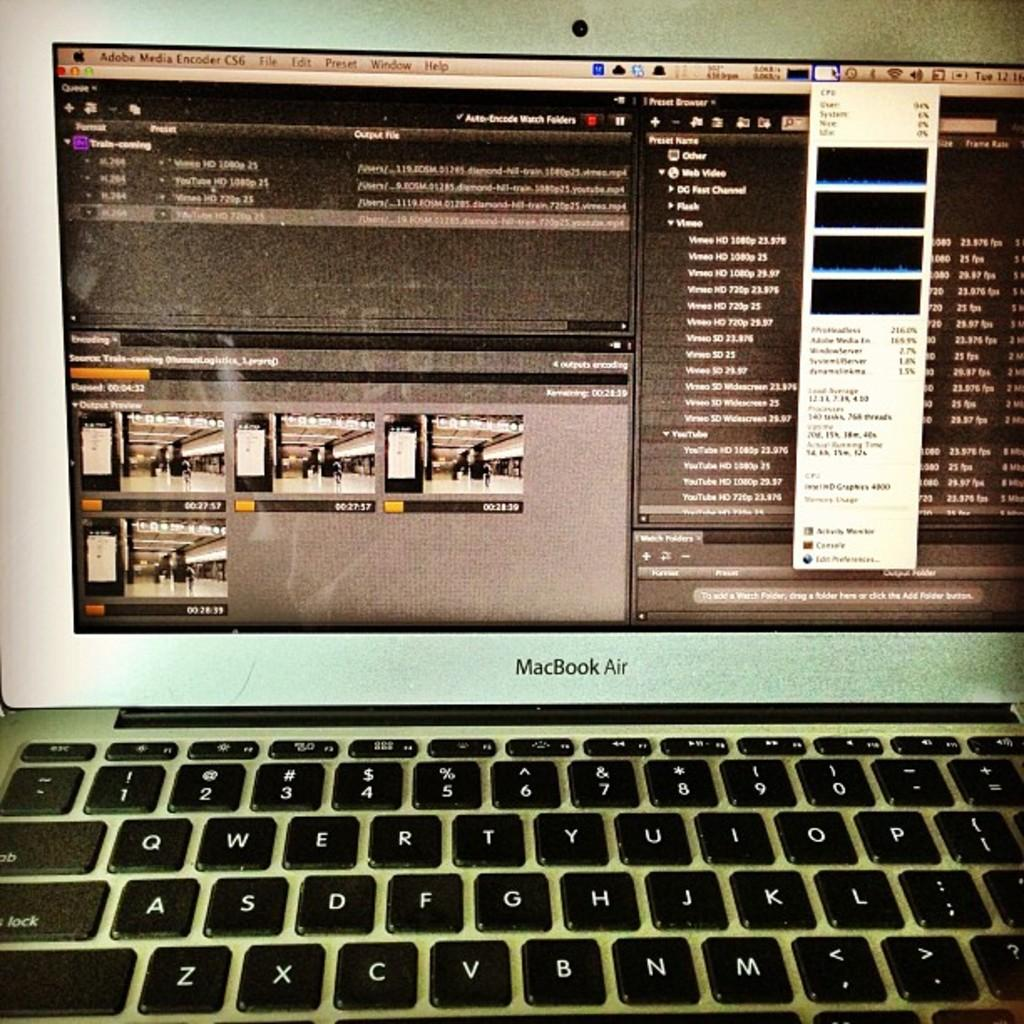What electronic device is present in the image? There is a laptop in the image. What is the current state of the laptop? The laptop is opened. What part of the laptop is visible in the image? The keyboard of the laptop is visible. What is being displayed on the laptop's monitor? There is a window displayed on the laptop's monitor. What is the name of the baby playing with the laptop in the image? There is no baby present in the image; it only features a laptop with a window displayed on its monitor. 